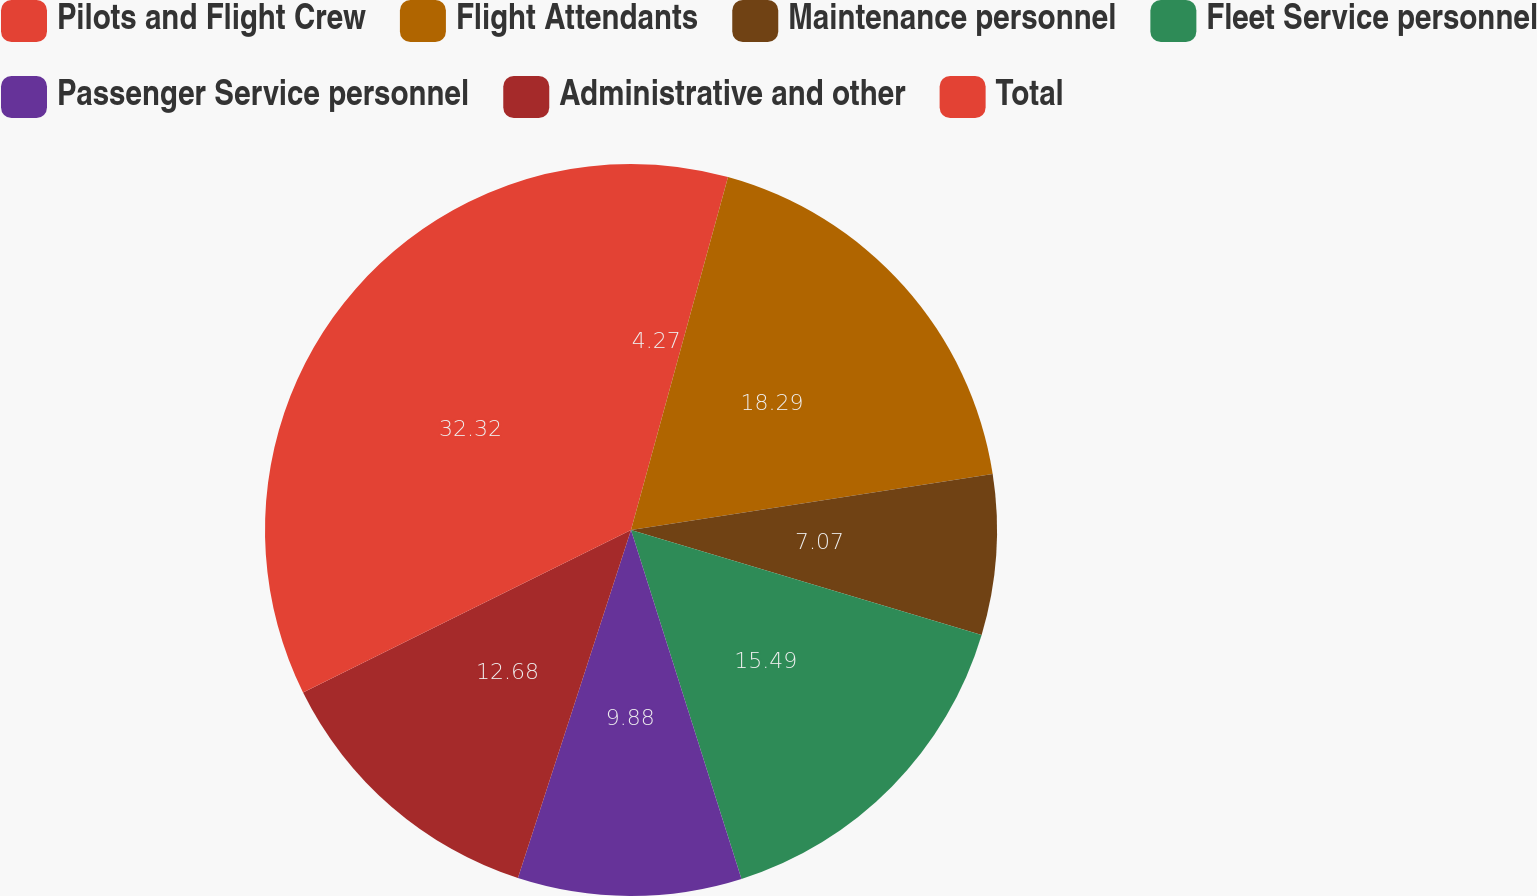<chart> <loc_0><loc_0><loc_500><loc_500><pie_chart><fcel>Pilots and Flight Crew<fcel>Flight Attendants<fcel>Maintenance personnel<fcel>Fleet Service personnel<fcel>Passenger Service personnel<fcel>Administrative and other<fcel>Total<nl><fcel>4.27%<fcel>18.29%<fcel>7.07%<fcel>15.49%<fcel>9.88%<fcel>12.68%<fcel>32.32%<nl></chart> 